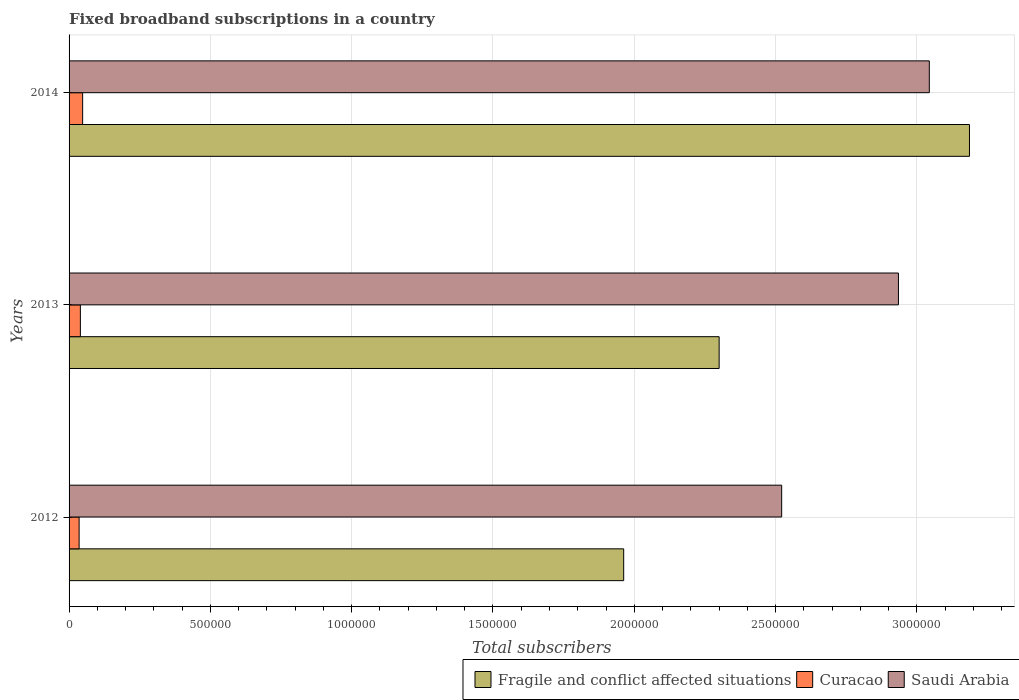How many groups of bars are there?
Your answer should be compact. 3. Are the number of bars per tick equal to the number of legend labels?
Keep it short and to the point. Yes. Are the number of bars on each tick of the Y-axis equal?
Your answer should be very brief. Yes. How many bars are there on the 2nd tick from the bottom?
Give a very brief answer. 3. What is the label of the 3rd group of bars from the top?
Provide a succinct answer. 2012. What is the number of broadband subscriptions in Curacao in 2013?
Ensure brevity in your answer.  4.00e+04. Across all years, what is the maximum number of broadband subscriptions in Saudi Arabia?
Provide a succinct answer. 3.04e+06. Across all years, what is the minimum number of broadband subscriptions in Curacao?
Your response must be concise. 3.56e+04. What is the total number of broadband subscriptions in Fragile and conflict affected situations in the graph?
Provide a succinct answer. 7.45e+06. What is the difference between the number of broadband subscriptions in Curacao in 2012 and that in 2013?
Offer a terse response. -4418. What is the difference between the number of broadband subscriptions in Saudi Arabia in 2014 and the number of broadband subscriptions in Curacao in 2012?
Ensure brevity in your answer.  3.01e+06. What is the average number of broadband subscriptions in Curacao per year?
Your response must be concise. 4.12e+04. In the year 2012, what is the difference between the number of broadband subscriptions in Fragile and conflict affected situations and number of broadband subscriptions in Curacao?
Keep it short and to the point. 1.93e+06. In how many years, is the number of broadband subscriptions in Saudi Arabia greater than 2200000 ?
Your answer should be compact. 3. What is the ratio of the number of broadband subscriptions in Saudi Arabia in 2012 to that in 2014?
Your answer should be compact. 0.83. What is the difference between the highest and the second highest number of broadband subscriptions in Saudi Arabia?
Your answer should be compact. 1.09e+05. What is the difference between the highest and the lowest number of broadband subscriptions in Curacao?
Ensure brevity in your answer.  1.24e+04. In how many years, is the number of broadband subscriptions in Fragile and conflict affected situations greater than the average number of broadband subscriptions in Fragile and conflict affected situations taken over all years?
Your answer should be compact. 1. Is the sum of the number of broadband subscriptions in Saudi Arabia in 2012 and 2014 greater than the maximum number of broadband subscriptions in Curacao across all years?
Your answer should be very brief. Yes. What does the 3rd bar from the top in 2014 represents?
Provide a succinct answer. Fragile and conflict affected situations. What does the 2nd bar from the bottom in 2014 represents?
Make the answer very short. Curacao. How many bars are there?
Give a very brief answer. 9. Are all the bars in the graph horizontal?
Your response must be concise. Yes. Are the values on the major ticks of X-axis written in scientific E-notation?
Offer a very short reply. No. Does the graph contain grids?
Offer a very short reply. Yes. How are the legend labels stacked?
Ensure brevity in your answer.  Horizontal. What is the title of the graph?
Your answer should be very brief. Fixed broadband subscriptions in a country. What is the label or title of the X-axis?
Give a very brief answer. Total subscribers. What is the Total subscribers in Fragile and conflict affected situations in 2012?
Keep it short and to the point. 1.96e+06. What is the Total subscribers in Curacao in 2012?
Ensure brevity in your answer.  3.56e+04. What is the Total subscribers in Saudi Arabia in 2012?
Offer a very short reply. 2.52e+06. What is the Total subscribers in Fragile and conflict affected situations in 2013?
Offer a very short reply. 2.30e+06. What is the Total subscribers of Curacao in 2013?
Your answer should be compact. 4.00e+04. What is the Total subscribers in Saudi Arabia in 2013?
Ensure brevity in your answer.  2.93e+06. What is the Total subscribers of Fragile and conflict affected situations in 2014?
Give a very brief answer. 3.19e+06. What is the Total subscribers in Curacao in 2014?
Ensure brevity in your answer.  4.80e+04. What is the Total subscribers of Saudi Arabia in 2014?
Keep it short and to the point. 3.04e+06. Across all years, what is the maximum Total subscribers of Fragile and conflict affected situations?
Your response must be concise. 3.19e+06. Across all years, what is the maximum Total subscribers in Curacao?
Your answer should be compact. 4.80e+04. Across all years, what is the maximum Total subscribers in Saudi Arabia?
Your answer should be very brief. 3.04e+06. Across all years, what is the minimum Total subscribers in Fragile and conflict affected situations?
Provide a short and direct response. 1.96e+06. Across all years, what is the minimum Total subscribers of Curacao?
Your response must be concise. 3.56e+04. Across all years, what is the minimum Total subscribers of Saudi Arabia?
Keep it short and to the point. 2.52e+06. What is the total Total subscribers of Fragile and conflict affected situations in the graph?
Give a very brief answer. 7.45e+06. What is the total Total subscribers of Curacao in the graph?
Your answer should be compact. 1.24e+05. What is the total Total subscribers of Saudi Arabia in the graph?
Offer a terse response. 8.50e+06. What is the difference between the Total subscribers of Fragile and conflict affected situations in 2012 and that in 2013?
Provide a short and direct response. -3.38e+05. What is the difference between the Total subscribers of Curacao in 2012 and that in 2013?
Provide a short and direct response. -4418. What is the difference between the Total subscribers of Saudi Arabia in 2012 and that in 2013?
Your answer should be very brief. -4.13e+05. What is the difference between the Total subscribers of Fragile and conflict affected situations in 2012 and that in 2014?
Provide a short and direct response. -1.22e+06. What is the difference between the Total subscribers in Curacao in 2012 and that in 2014?
Give a very brief answer. -1.24e+04. What is the difference between the Total subscribers in Saudi Arabia in 2012 and that in 2014?
Give a very brief answer. -5.22e+05. What is the difference between the Total subscribers in Fragile and conflict affected situations in 2013 and that in 2014?
Give a very brief answer. -8.86e+05. What is the difference between the Total subscribers of Curacao in 2013 and that in 2014?
Provide a succinct answer. -8000. What is the difference between the Total subscribers of Saudi Arabia in 2013 and that in 2014?
Keep it short and to the point. -1.09e+05. What is the difference between the Total subscribers in Fragile and conflict affected situations in 2012 and the Total subscribers in Curacao in 2013?
Your answer should be compact. 1.92e+06. What is the difference between the Total subscribers of Fragile and conflict affected situations in 2012 and the Total subscribers of Saudi Arabia in 2013?
Your response must be concise. -9.72e+05. What is the difference between the Total subscribers in Curacao in 2012 and the Total subscribers in Saudi Arabia in 2013?
Give a very brief answer. -2.90e+06. What is the difference between the Total subscribers in Fragile and conflict affected situations in 2012 and the Total subscribers in Curacao in 2014?
Ensure brevity in your answer.  1.91e+06. What is the difference between the Total subscribers in Fragile and conflict affected situations in 2012 and the Total subscribers in Saudi Arabia in 2014?
Provide a succinct answer. -1.08e+06. What is the difference between the Total subscribers of Curacao in 2012 and the Total subscribers of Saudi Arabia in 2014?
Offer a terse response. -3.01e+06. What is the difference between the Total subscribers in Fragile and conflict affected situations in 2013 and the Total subscribers in Curacao in 2014?
Make the answer very short. 2.25e+06. What is the difference between the Total subscribers of Fragile and conflict affected situations in 2013 and the Total subscribers of Saudi Arabia in 2014?
Provide a short and direct response. -7.44e+05. What is the difference between the Total subscribers of Curacao in 2013 and the Total subscribers of Saudi Arabia in 2014?
Keep it short and to the point. -3.00e+06. What is the average Total subscribers in Fragile and conflict affected situations per year?
Offer a very short reply. 2.48e+06. What is the average Total subscribers in Curacao per year?
Provide a succinct answer. 4.12e+04. What is the average Total subscribers in Saudi Arabia per year?
Offer a terse response. 2.83e+06. In the year 2012, what is the difference between the Total subscribers of Fragile and conflict affected situations and Total subscribers of Curacao?
Offer a terse response. 1.93e+06. In the year 2012, what is the difference between the Total subscribers of Fragile and conflict affected situations and Total subscribers of Saudi Arabia?
Provide a short and direct response. -5.59e+05. In the year 2012, what is the difference between the Total subscribers of Curacao and Total subscribers of Saudi Arabia?
Offer a terse response. -2.49e+06. In the year 2013, what is the difference between the Total subscribers of Fragile and conflict affected situations and Total subscribers of Curacao?
Your answer should be very brief. 2.26e+06. In the year 2013, what is the difference between the Total subscribers of Fragile and conflict affected situations and Total subscribers of Saudi Arabia?
Ensure brevity in your answer.  -6.34e+05. In the year 2013, what is the difference between the Total subscribers in Curacao and Total subscribers in Saudi Arabia?
Give a very brief answer. -2.89e+06. In the year 2014, what is the difference between the Total subscribers in Fragile and conflict affected situations and Total subscribers in Curacao?
Keep it short and to the point. 3.14e+06. In the year 2014, what is the difference between the Total subscribers in Fragile and conflict affected situations and Total subscribers in Saudi Arabia?
Provide a succinct answer. 1.42e+05. In the year 2014, what is the difference between the Total subscribers in Curacao and Total subscribers in Saudi Arabia?
Offer a terse response. -3.00e+06. What is the ratio of the Total subscribers of Fragile and conflict affected situations in 2012 to that in 2013?
Offer a very short reply. 0.85. What is the ratio of the Total subscribers of Curacao in 2012 to that in 2013?
Your answer should be very brief. 0.89. What is the ratio of the Total subscribers of Saudi Arabia in 2012 to that in 2013?
Ensure brevity in your answer.  0.86. What is the ratio of the Total subscribers in Fragile and conflict affected situations in 2012 to that in 2014?
Offer a terse response. 0.62. What is the ratio of the Total subscribers in Curacao in 2012 to that in 2014?
Keep it short and to the point. 0.74. What is the ratio of the Total subscribers of Saudi Arabia in 2012 to that in 2014?
Ensure brevity in your answer.  0.83. What is the ratio of the Total subscribers in Fragile and conflict affected situations in 2013 to that in 2014?
Keep it short and to the point. 0.72. What is the ratio of the Total subscribers in Curacao in 2013 to that in 2014?
Your response must be concise. 0.83. What is the ratio of the Total subscribers in Saudi Arabia in 2013 to that in 2014?
Offer a very short reply. 0.96. What is the difference between the highest and the second highest Total subscribers of Fragile and conflict affected situations?
Your answer should be compact. 8.86e+05. What is the difference between the highest and the second highest Total subscribers of Curacao?
Offer a very short reply. 8000. What is the difference between the highest and the second highest Total subscribers of Saudi Arabia?
Provide a succinct answer. 1.09e+05. What is the difference between the highest and the lowest Total subscribers in Fragile and conflict affected situations?
Provide a succinct answer. 1.22e+06. What is the difference between the highest and the lowest Total subscribers of Curacao?
Your answer should be very brief. 1.24e+04. What is the difference between the highest and the lowest Total subscribers in Saudi Arabia?
Your answer should be very brief. 5.22e+05. 